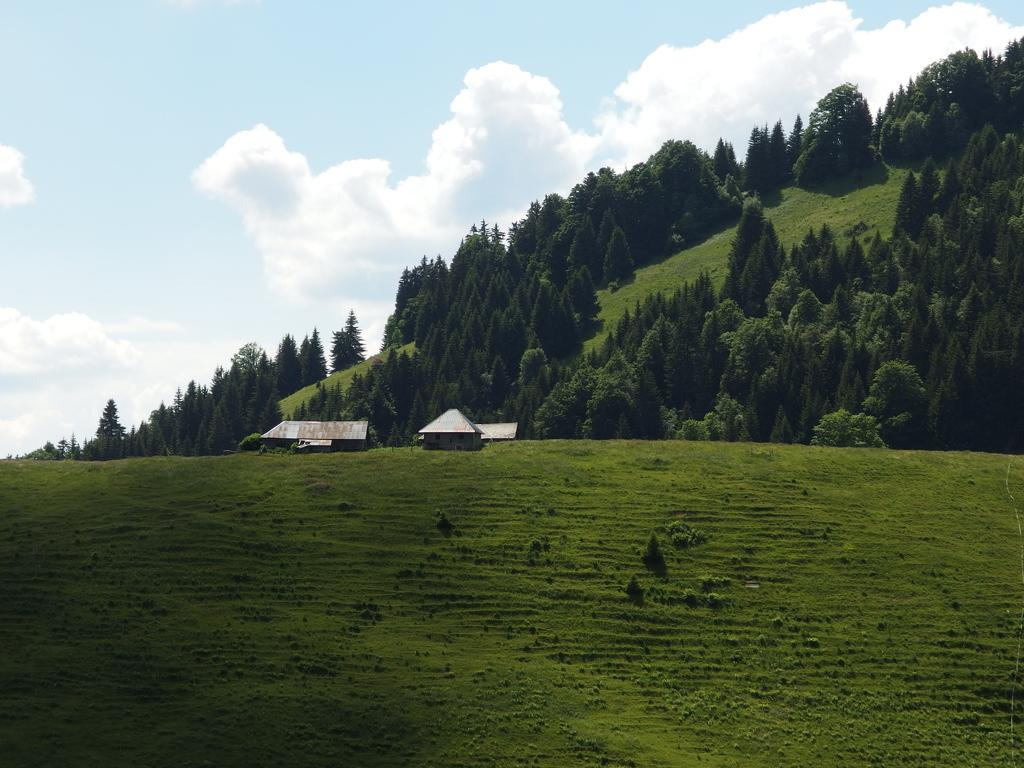What type of vegetation is present in the image? There is grass in the image. What structures can be seen in the image? There are houses in the image. What other natural elements are present in the image? There are trees in the image. Where are the houses and trees located in the image? The houses and trees are on a hill. What can be seen in the background of the image? The sky is visible in the background of the image. Can you tell me how many matches are being used to light the houses in the image? There are no matches present in the image, and the houses are not being lit by any fire source. What is the sister doing in the image? There is no mention of a sister or any person in the image. 